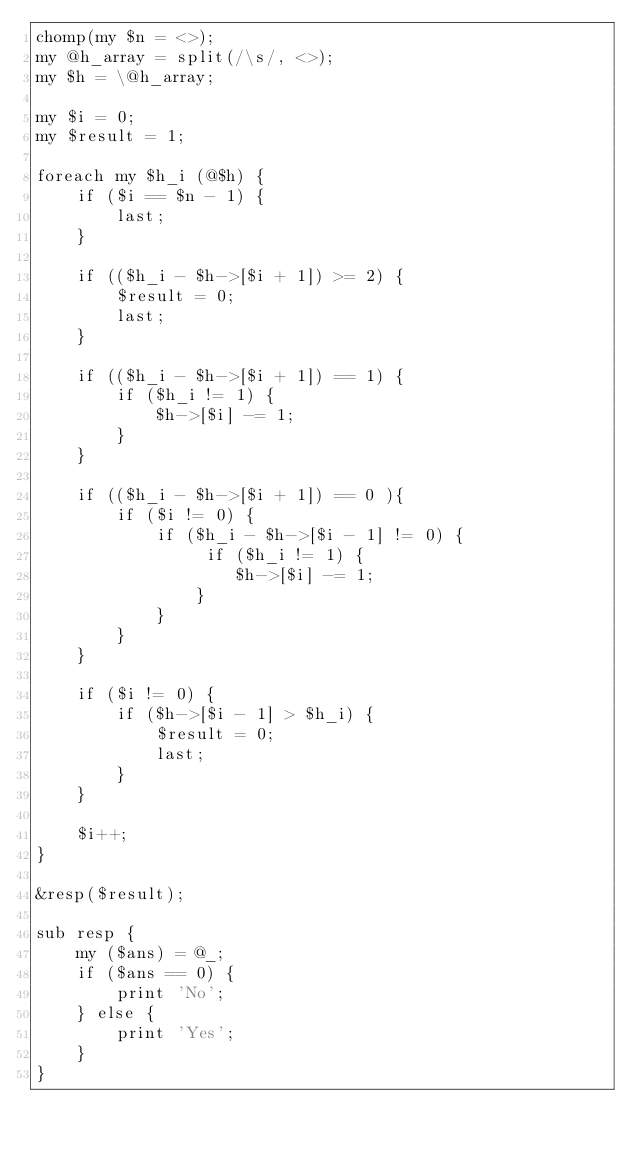<code> <loc_0><loc_0><loc_500><loc_500><_Perl_>chomp(my $n = <>);
my @h_array = split(/\s/, <>);
my $h = \@h_array;

my $i = 0;
my $result = 1;

foreach my $h_i (@$h) {
    if ($i == $n - 1) {
        last;
    }

    if (($h_i - $h->[$i + 1]) >= 2) {
        $result = 0;
        last;
    }

    if (($h_i - $h->[$i + 1]) == 1) {
        if ($h_i != 1) {
            $h->[$i] -= 1;
        }
    }

    if (($h_i - $h->[$i + 1]) == 0 ){
        if ($i != 0) {
            if ($h_i - $h->[$i - 1] != 0) {
                 if ($h_i != 1) {
                    $h->[$i] -= 1;
                }
            }
        }
    }

    if ($i != 0) {
        if ($h->[$i - 1] > $h_i) {
            $result = 0;
            last;
        }
    }

    $i++;
}

&resp($result);

sub resp {
    my ($ans) = @_;
    if ($ans == 0) {
        print 'No';
    } else {
        print 'Yes';
    }
}
</code> 